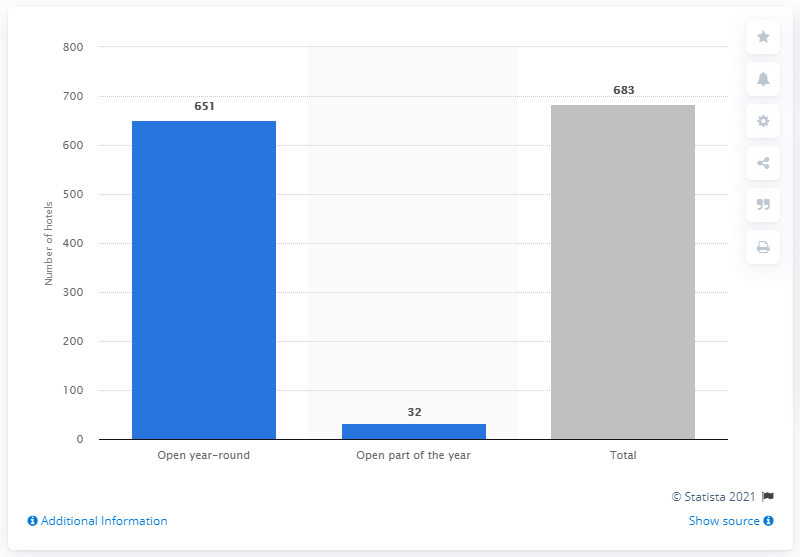Identify some key points in this picture. In 2020, there were 683 hotels in Finland. In Finland, 32 of its hotels are seasonally open. 